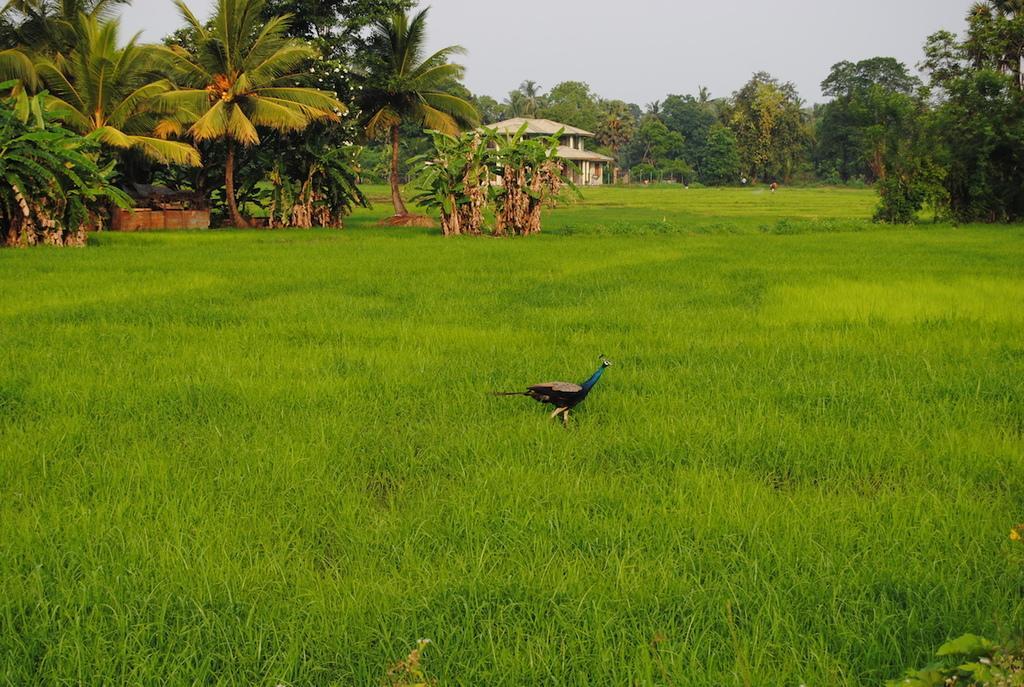In one or two sentences, can you explain what this image depicts? In this image, we can see a peacock on the grass. At the top of the image, we can see trees, plants, shelter and sky. 